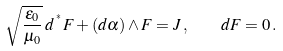<formula> <loc_0><loc_0><loc_500><loc_500>\sqrt { \frac { \varepsilon _ { 0 } } { \mu _ { 0 } } } \, d \, ^ { ^ { * } } F + ( d \alpha ) \wedge F = J \, , \quad d F = 0 \, .</formula> 